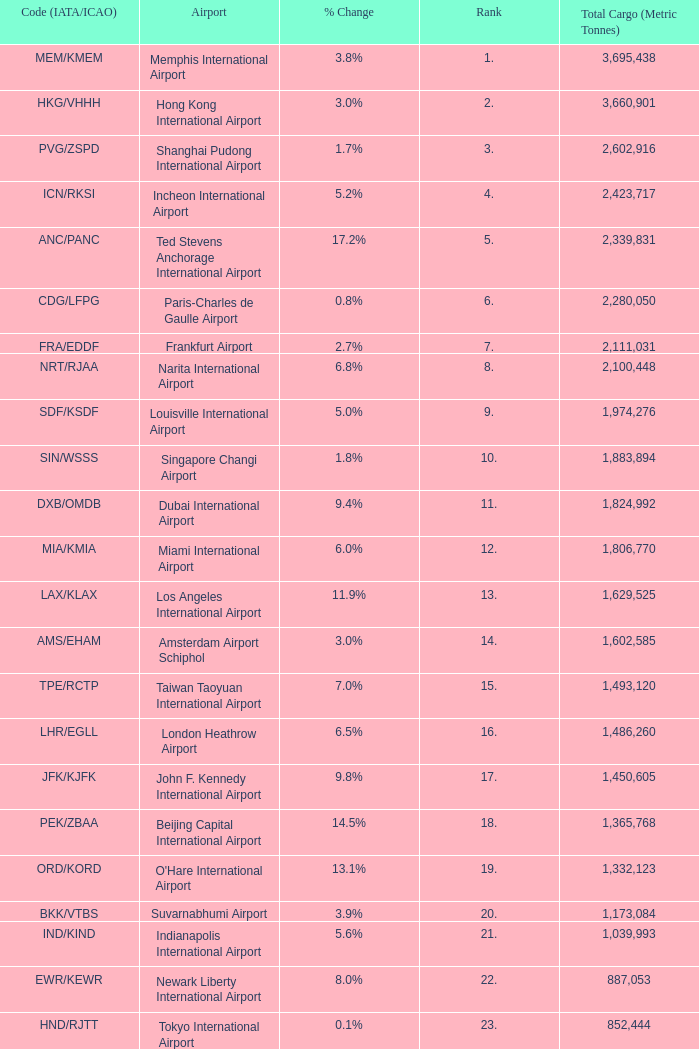What is the rank for ord/kord with more than 1,332,123 total cargo? None. 